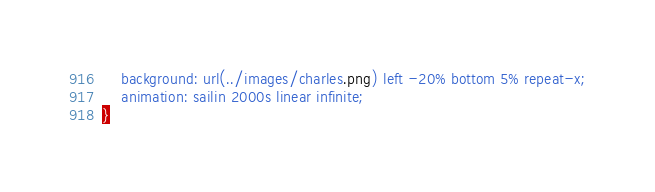<code> <loc_0><loc_0><loc_500><loc_500><_CSS_>    background: url(../images/charles.png) left -20% bottom 5% repeat-x;
    animation: sailin 2000s linear infinite;
}
</code> 